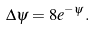<formula> <loc_0><loc_0><loc_500><loc_500>\Delta \psi = 8 e ^ { - \psi } .</formula> 